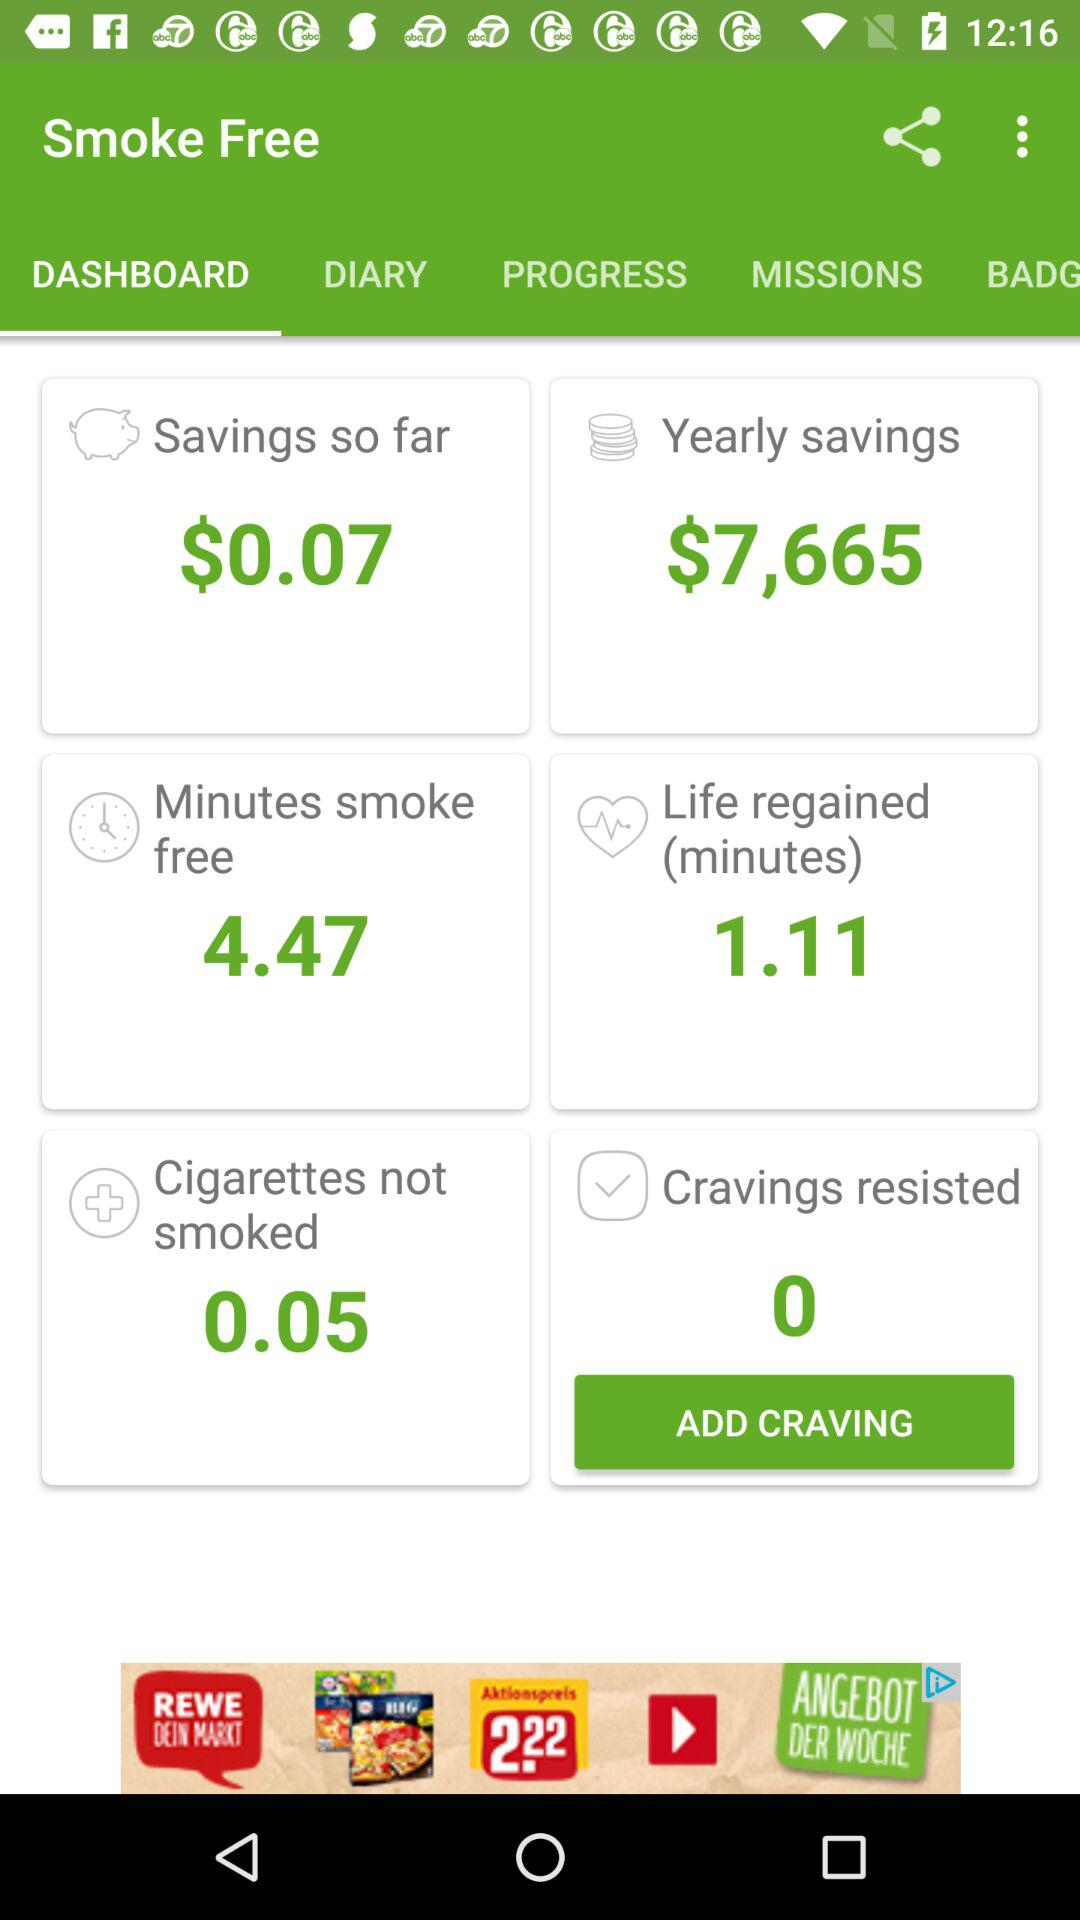What is the savings amount so far? The savings amount so far is $0.07. 